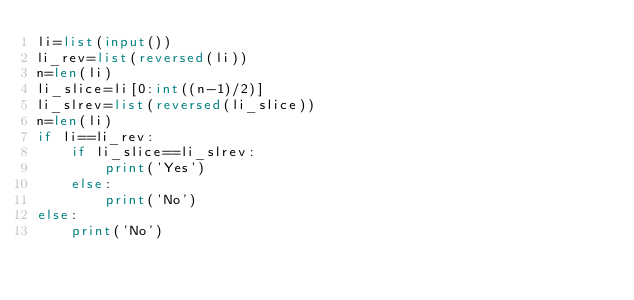Convert code to text. <code><loc_0><loc_0><loc_500><loc_500><_Python_>li=list(input())
li_rev=list(reversed(li))
n=len(li)
li_slice=li[0:int((n-1)/2)]
li_slrev=list(reversed(li_slice))
n=len(li)
if li==li_rev:
    if li_slice==li_slrev:
        print('Yes')
    else:
        print('No')
else:
    print('No')</code> 